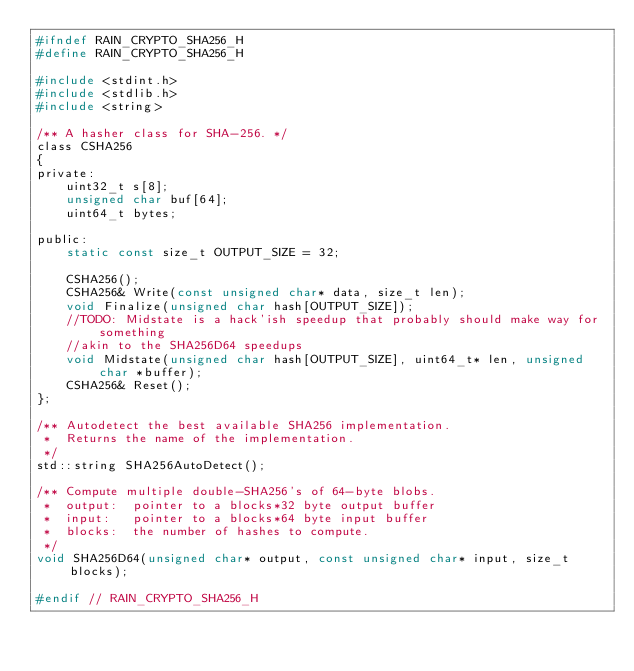<code> <loc_0><loc_0><loc_500><loc_500><_C_>#ifndef RAIN_CRYPTO_SHA256_H
#define RAIN_CRYPTO_SHA256_H

#include <stdint.h>
#include <stdlib.h>
#include <string>

/** A hasher class for SHA-256. */
class CSHA256
{
private:
    uint32_t s[8];
    unsigned char buf[64];
    uint64_t bytes;

public:
    static const size_t OUTPUT_SIZE = 32;

    CSHA256();
    CSHA256& Write(const unsigned char* data, size_t len);
    void Finalize(unsigned char hash[OUTPUT_SIZE]);
    //TODO: Midstate is a hack'ish speedup that probably should make way for something
    //akin to the SHA256D64 speedups
    void Midstate(unsigned char hash[OUTPUT_SIZE], uint64_t* len, unsigned char *buffer);
    CSHA256& Reset();
};

/** Autodetect the best available SHA256 implementation.
 *  Returns the name of the implementation.
 */
std::string SHA256AutoDetect();

/** Compute multiple double-SHA256's of 64-byte blobs.
 *  output:  pointer to a blocks*32 byte output buffer
 *  input:   pointer to a blocks*64 byte input buffer
 *  blocks:  the number of hashes to compute.
 */
void SHA256D64(unsigned char* output, const unsigned char* input, size_t blocks);

#endif // RAIN_CRYPTO_SHA256_H
</code> 